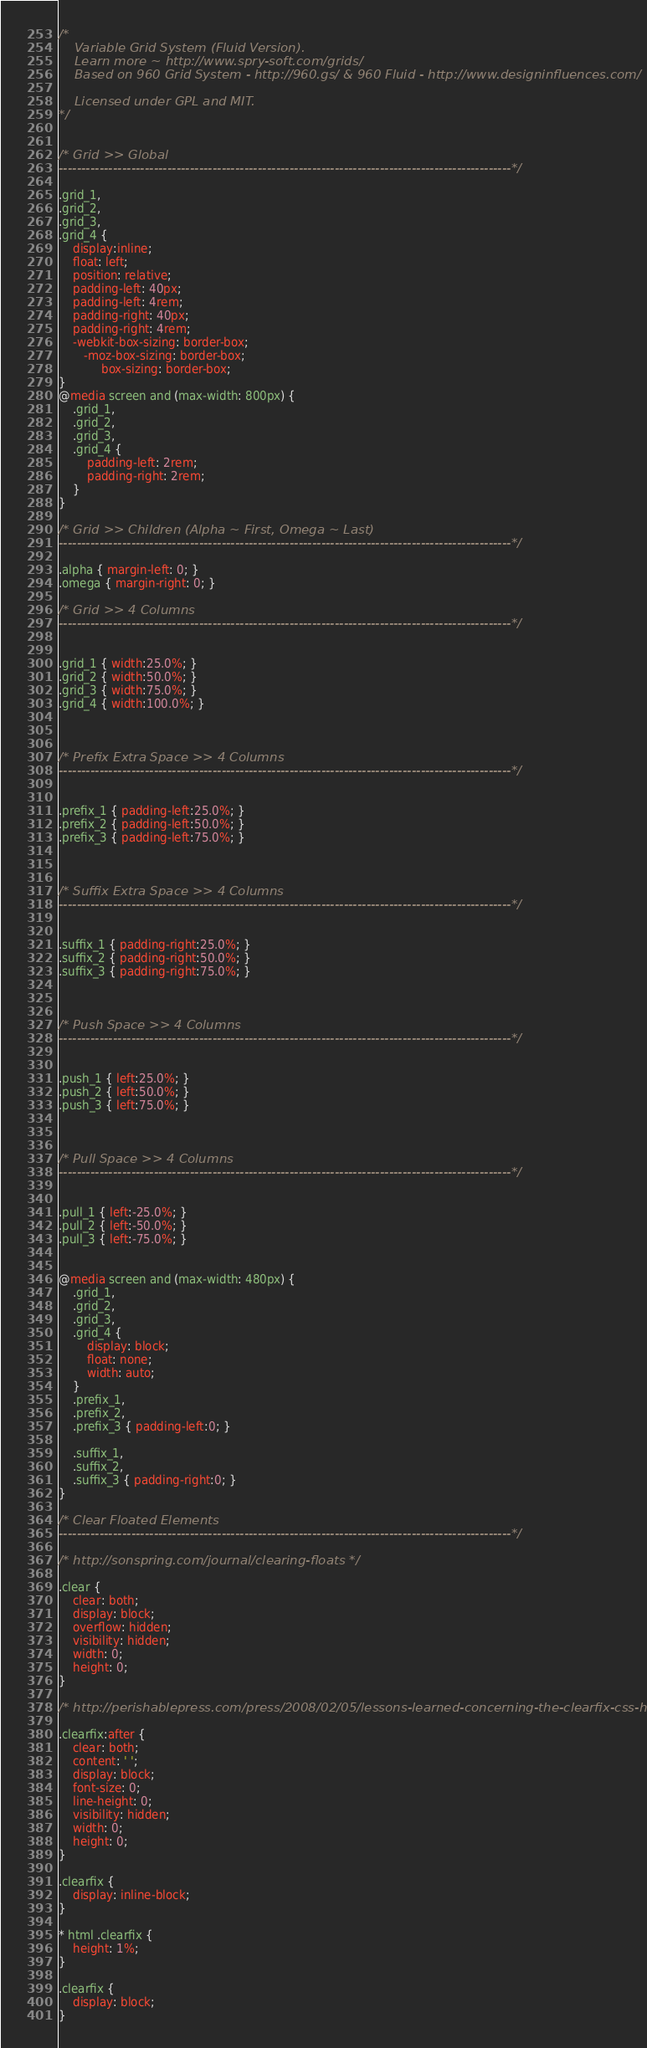<code> <loc_0><loc_0><loc_500><loc_500><_CSS_>/*
	Variable Grid System (Fluid Version).
	Learn more ~ http://www.spry-soft.com/grids/
	Based on 960 Grid System - http://960.gs/ & 960 Fluid - http://www.designinfluences.com/

	Licensed under GPL and MIT.
*/


/* Grid >> Global
----------------------------------------------------------------------------------------------------*/

.grid_1,
.grid_2,
.grid_3,
.grid_4 {
	display:inline;
	float: left;
	position: relative;
	padding-left: 40px;
	padding-left: 4rem;
	padding-right: 40px;
	padding-right: 4rem;
	-webkit-box-sizing: border-box;
	   -moz-box-sizing: border-box;
	        box-sizing: border-box;
}
@media screen and (max-width: 800px) {
	.grid_1,
	.grid_2,
	.grid_3,
	.grid_4 {
		padding-left: 2rem;
		padding-right: 2rem;
	}
}

/* Grid >> Children (Alpha ~ First, Omega ~ Last)
----------------------------------------------------------------------------------------------------*/

.alpha { margin-left: 0; }
.omega { margin-right: 0; }

/* Grid >> 4 Columns
----------------------------------------------------------------------------------------------------*/


.grid_1 { width:25.0%; }
.grid_2 { width:50.0%; }
.grid_3 { width:75.0%; }
.grid_4 { width:100.0%; }



/* Prefix Extra Space >> 4 Columns
----------------------------------------------------------------------------------------------------*/


.prefix_1 { padding-left:25.0%; }
.prefix_2 { padding-left:50.0%; }
.prefix_3 { padding-left:75.0%; }



/* Suffix Extra Space >> 4 Columns
----------------------------------------------------------------------------------------------------*/


.suffix_1 { padding-right:25.0%; }
.suffix_2 { padding-right:50.0%; }
.suffix_3 { padding-right:75.0%; }



/* Push Space >> 4 Columns
----------------------------------------------------------------------------------------------------*/


.push_1 { left:25.0%; }
.push_2 { left:50.0%; }
.push_3 { left:75.0%; }



/* Pull Space >> 4 Columns
----------------------------------------------------------------------------------------------------*/


.pull_1 { left:-25.0%; }
.pull_2 { left:-50.0%; }
.pull_3 { left:-75.0%; }


@media screen and (max-width: 480px) {
	.grid_1,
	.grid_2,
	.grid_3,
	.grid_4 {
		display: block;
		float: none;
		width: auto;
	}
	.prefix_1,
	.prefix_2,
	.prefix_3 { padding-left:0; }

	.suffix_1,
	.suffix_2,
	.suffix_3 { padding-right:0; }
}

/* Clear Floated Elements
----------------------------------------------------------------------------------------------------*/

/* http://sonspring.com/journal/clearing-floats */

.clear {
	clear: both;
	display: block;
	overflow: hidden;
	visibility: hidden;
	width: 0;
	height: 0;
}

/* http://perishablepress.com/press/2008/02/05/lessons-learned-concerning-the-clearfix-css-hack */

.clearfix:after {
	clear: both;
	content: ' ';
	display: block;
	font-size: 0;
	line-height: 0;
	visibility: hidden;
	width: 0;
	height: 0;
}

.clearfix {
	display: inline-block;
}

* html .clearfix {
	height: 1%;
}

.clearfix {
	display: block;
}
</code> 